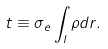Convert formula to latex. <formula><loc_0><loc_0><loc_500><loc_500>t \equiv \sigma _ { e } \int _ { l } \rho d r .</formula> 